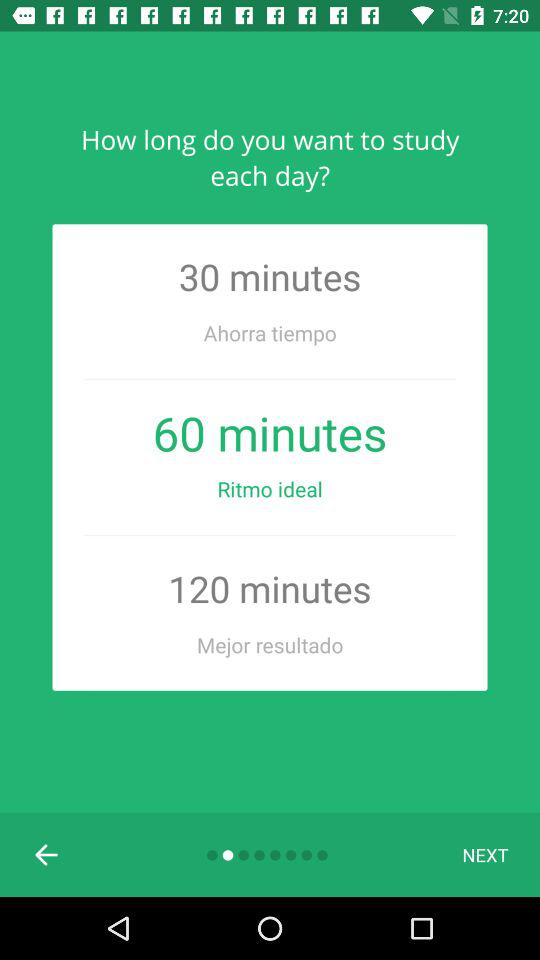How many minutes is the difference between the shortest and longest study time?
Answer the question using a single word or phrase. 90 